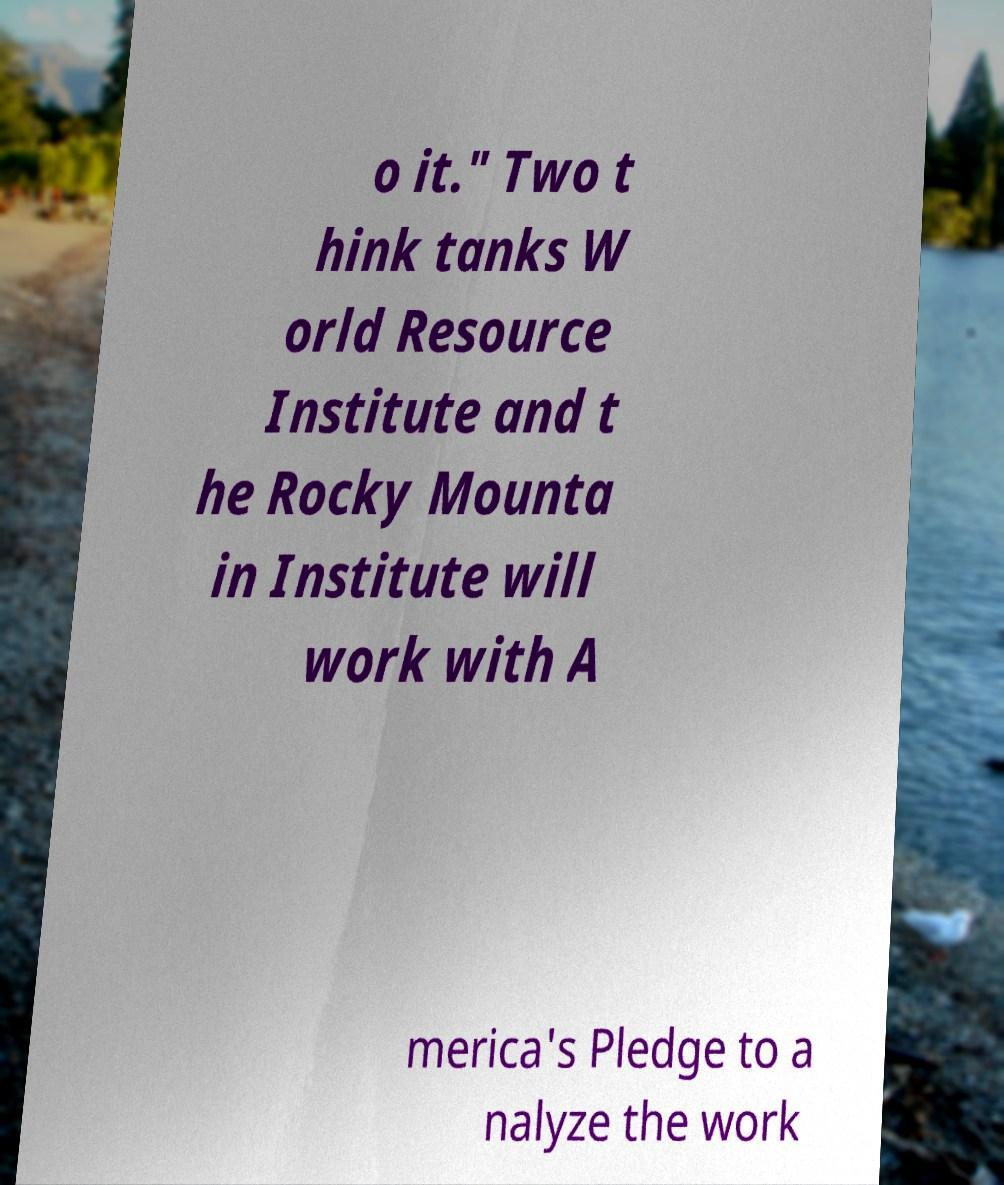There's text embedded in this image that I need extracted. Can you transcribe it verbatim? o it." Two t hink tanks W orld Resource Institute and t he Rocky Mounta in Institute will work with A merica's Pledge to a nalyze the work 